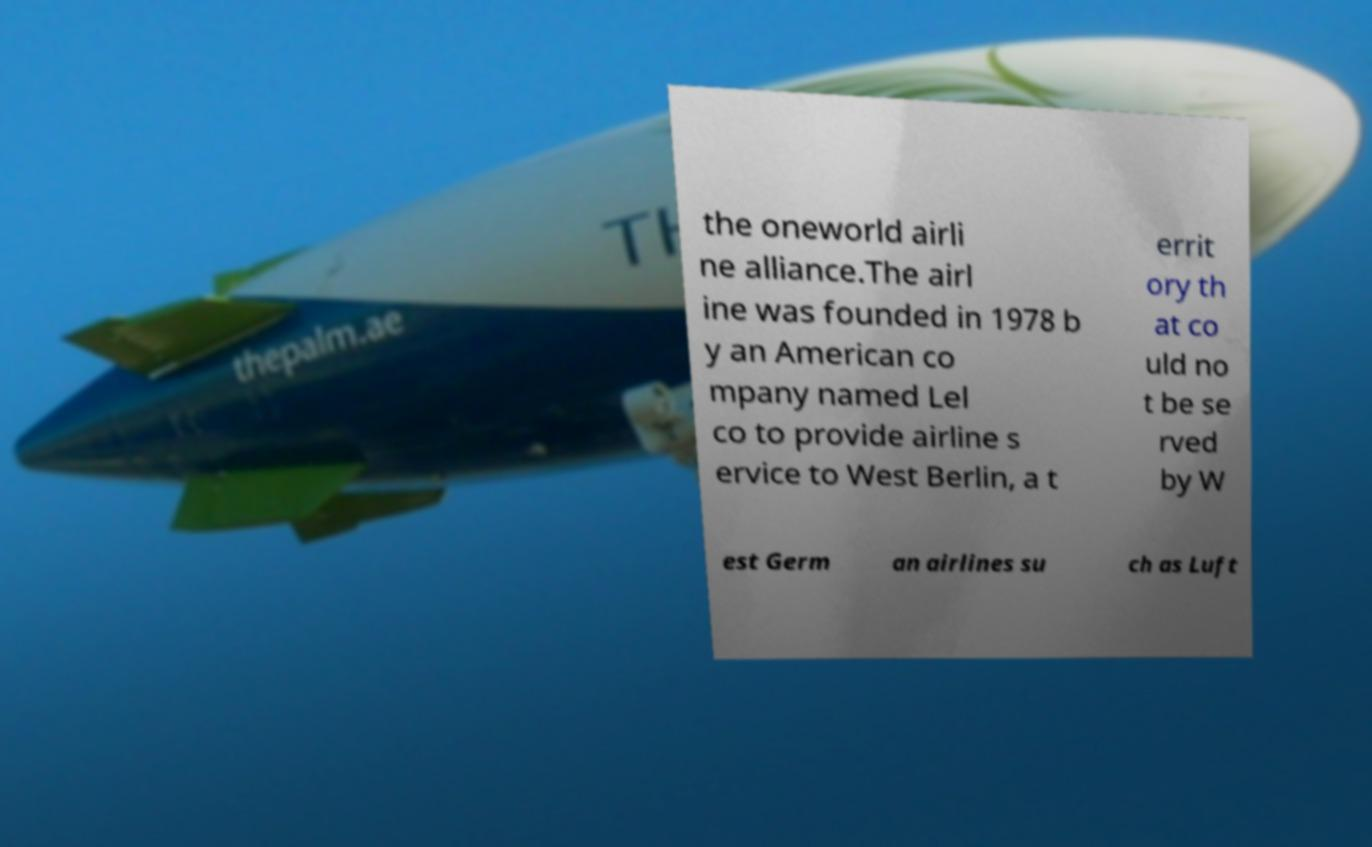There's text embedded in this image that I need extracted. Can you transcribe it verbatim? the oneworld airli ne alliance.The airl ine was founded in 1978 b y an American co mpany named Lel co to provide airline s ervice to West Berlin, a t errit ory th at co uld no t be se rved by W est Germ an airlines su ch as Luft 